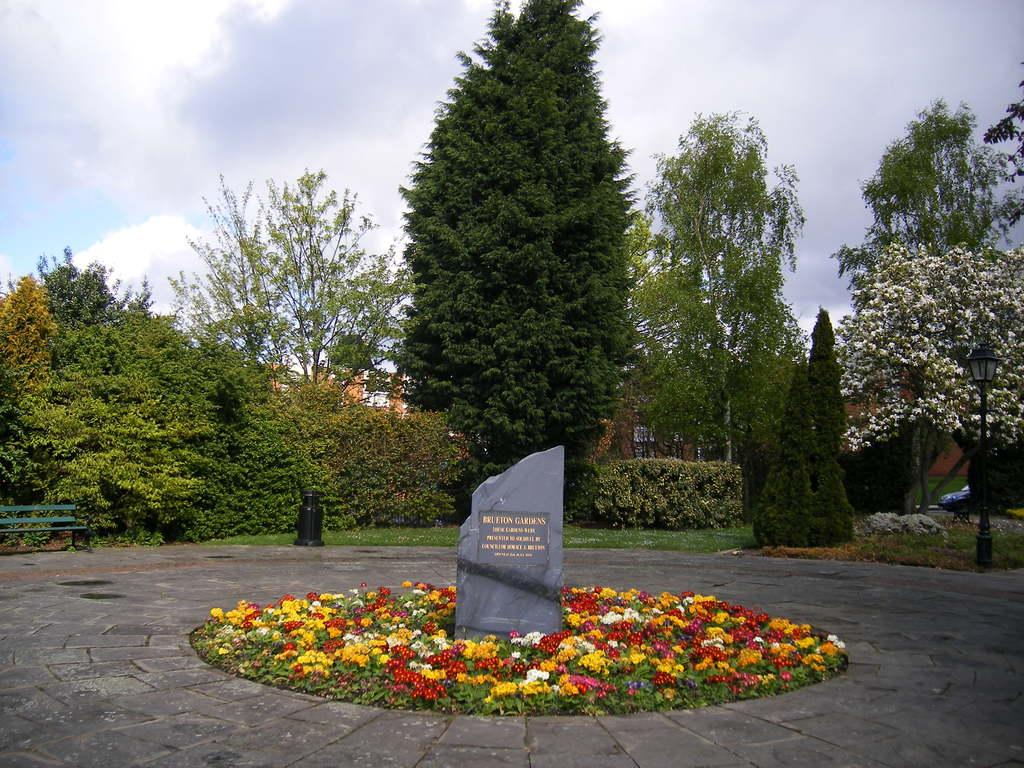What is the main object with text in the image? There is a stone with text in the image. What type of plants can be seen in the image? There are plants with flowers in the image. What kind of path is present in the image? There is a walkway in the image. What can be seen in the background of the image? The background of the image includes plants, trees, a bench, and a pole with a light. What is visible in the sky in the image? The sky is visible in the background of the image. What is the name of the person who wrote on the pencil in the image? There is no pencil present in the image, and therefore no writing or person's name can be observed. 